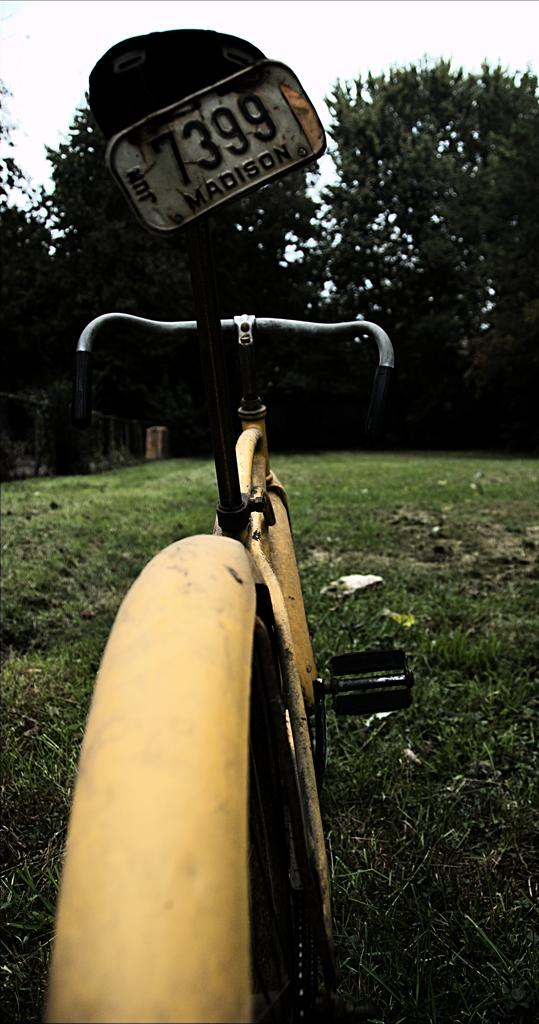What type of vehicle is in the image? There is a yellow cycle in the image. What is the ground surface like in the image? There is grass in the image. What type of vegetation is present in the image? There are green trees in the image. What type of boat can be seen sailing in the image? There is no boat present in the image; it features a yellow cycle and green trees. Can you see any wounds on the trees in the image? There are no wounds visible on the trees in the image; they appear to be healthy and green. 